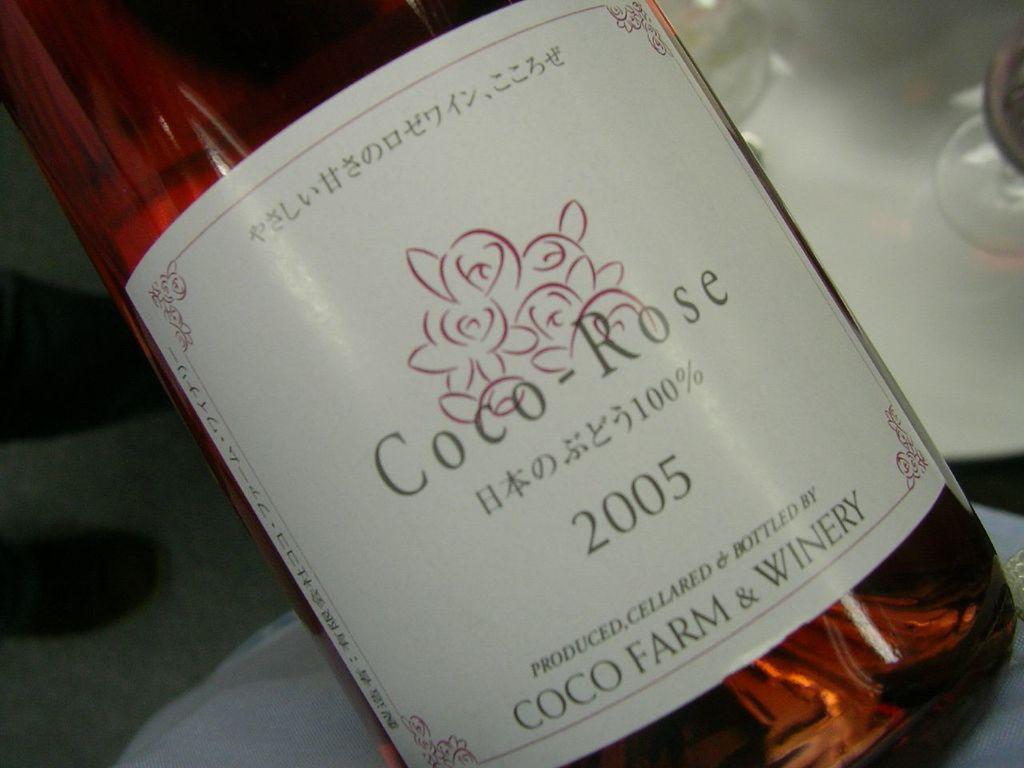Where was this wine bottled at?
Your answer should be very brief. Coco farm & winery. 